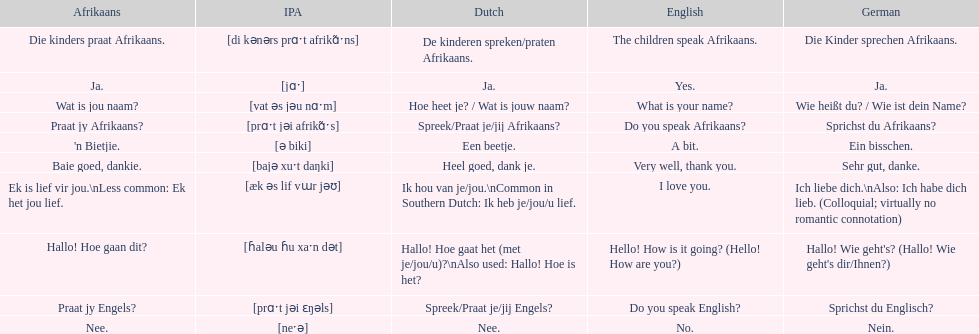How do you say 'yes' in afrikaans? Ja. 